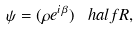<formula> <loc_0><loc_0><loc_500><loc_500>\psi = ( \rho e ^ { i \, \beta } ) ^ { \ } h a l f R ,</formula> 